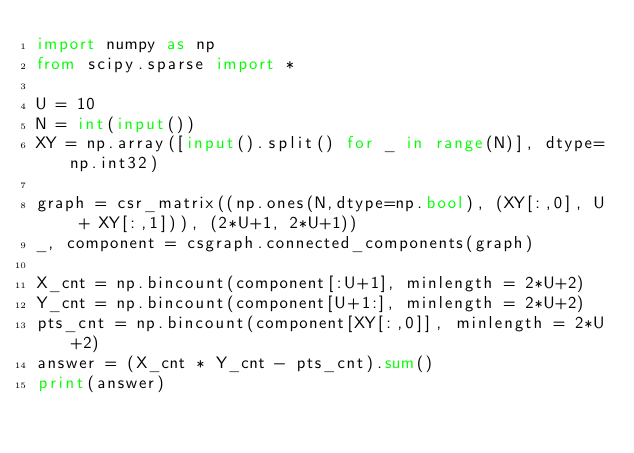<code> <loc_0><loc_0><loc_500><loc_500><_Python_>import numpy as np
from scipy.sparse import *

U = 10
N = int(input())
XY = np.array([input().split() for _ in range(N)], dtype=np.int32)

graph = csr_matrix((np.ones(N,dtype=np.bool), (XY[:,0], U + XY[:,1])), (2*U+1, 2*U+1))
_, component = csgraph.connected_components(graph)

X_cnt = np.bincount(component[:U+1], minlength = 2*U+2)
Y_cnt = np.bincount(component[U+1:], minlength = 2*U+2)
pts_cnt = np.bincount(component[XY[:,0]], minlength = 2*U+2)
answer = (X_cnt * Y_cnt - pts_cnt).sum()
print(answer)
</code> 